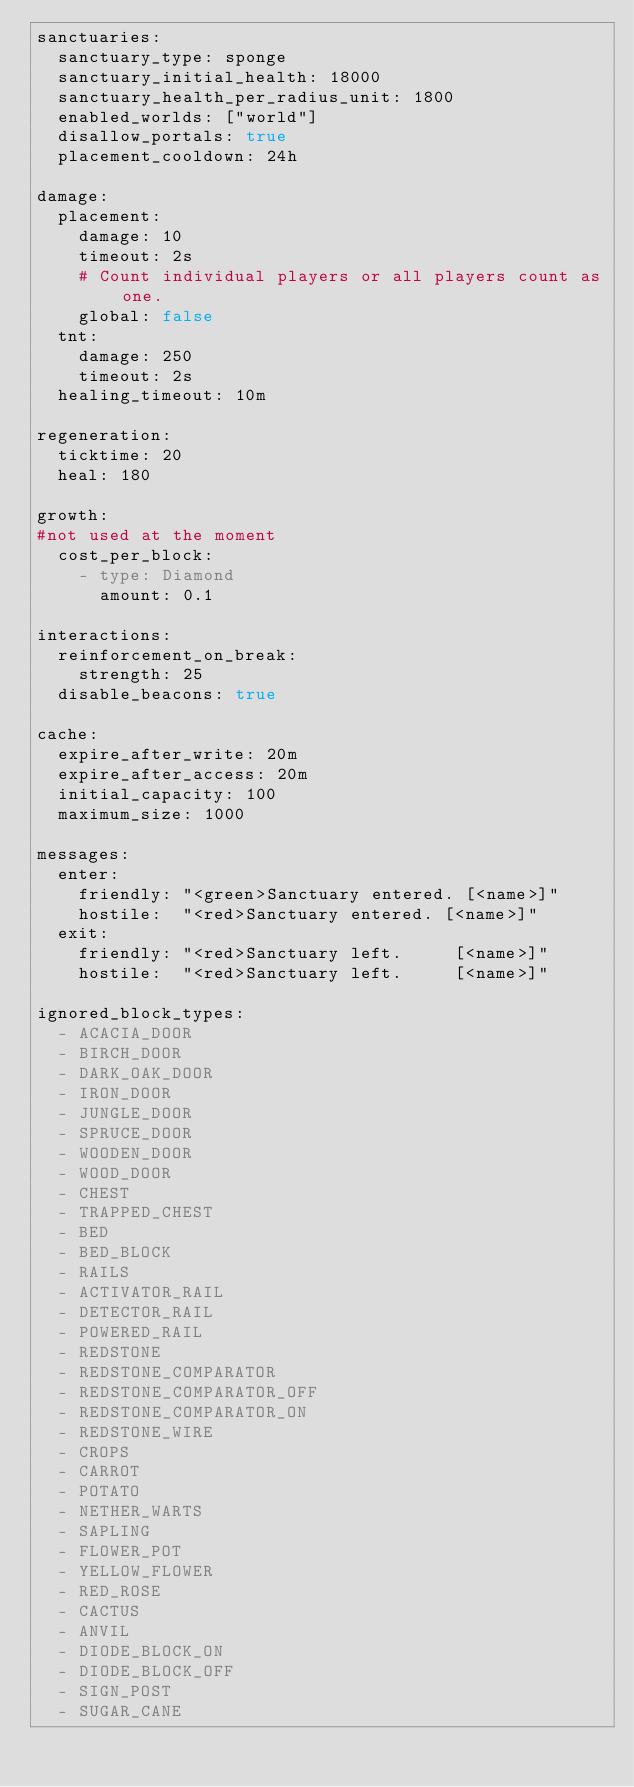<code> <loc_0><loc_0><loc_500><loc_500><_YAML_>sanctuaries:
  sanctuary_type: sponge
  sanctuary_initial_health: 18000
  sanctuary_health_per_radius_unit: 1800
  enabled_worlds: ["world"]
  disallow_portals: true
  placement_cooldown: 24h

damage:
  placement:
    damage: 10
    timeout: 2s
    # Count individual players or all players count as one.
    global: false
  tnt:
    damage: 250
    timeout: 2s
  healing_timeout: 10m

regeneration:
  ticktime: 20
  heal: 180

growth:
#not used at the moment
  cost_per_block:
    - type: Diamond
      amount: 0.1

interactions:
  reinforcement_on_break:
    strength: 25
  disable_beacons: true

cache:
  expire_after_write: 20m
  expire_after_access: 20m
  initial_capacity: 100
  maximum_size: 1000

messages:
  enter:
    friendly: "<green>Sanctuary entered. [<name>]"
    hostile:  "<red>Sanctuary entered. [<name>]"
  exit:
    friendly: "<red>Sanctuary left.     [<name>]"
    hostile:  "<red>Sanctuary left.     [<name>]"

ignored_block_types:
  - ACACIA_DOOR
  - BIRCH_DOOR
  - DARK_OAK_DOOR
  - IRON_DOOR
  - JUNGLE_DOOR
  - SPRUCE_DOOR
  - WOODEN_DOOR
  - WOOD_DOOR
  - CHEST
  - TRAPPED_CHEST
  - BED
  - BED_BLOCK
  - RAILS
  - ACTIVATOR_RAIL
  - DETECTOR_RAIL
  - POWERED_RAIL
  - REDSTONE
  - REDSTONE_COMPARATOR
  - REDSTONE_COMPARATOR_OFF
  - REDSTONE_COMPARATOR_ON
  - REDSTONE_WIRE
  - CROPS
  - CARROT
  - POTATO
  - NETHER_WARTS
  - SAPLING
  - FLOWER_POT
  - YELLOW_FLOWER
  - RED_ROSE
  - CACTUS
  - ANVIL
  - DIODE_BLOCK_ON
  - DIODE_BLOCK_OFF
  - SIGN_POST
  - SUGAR_CANE</code> 